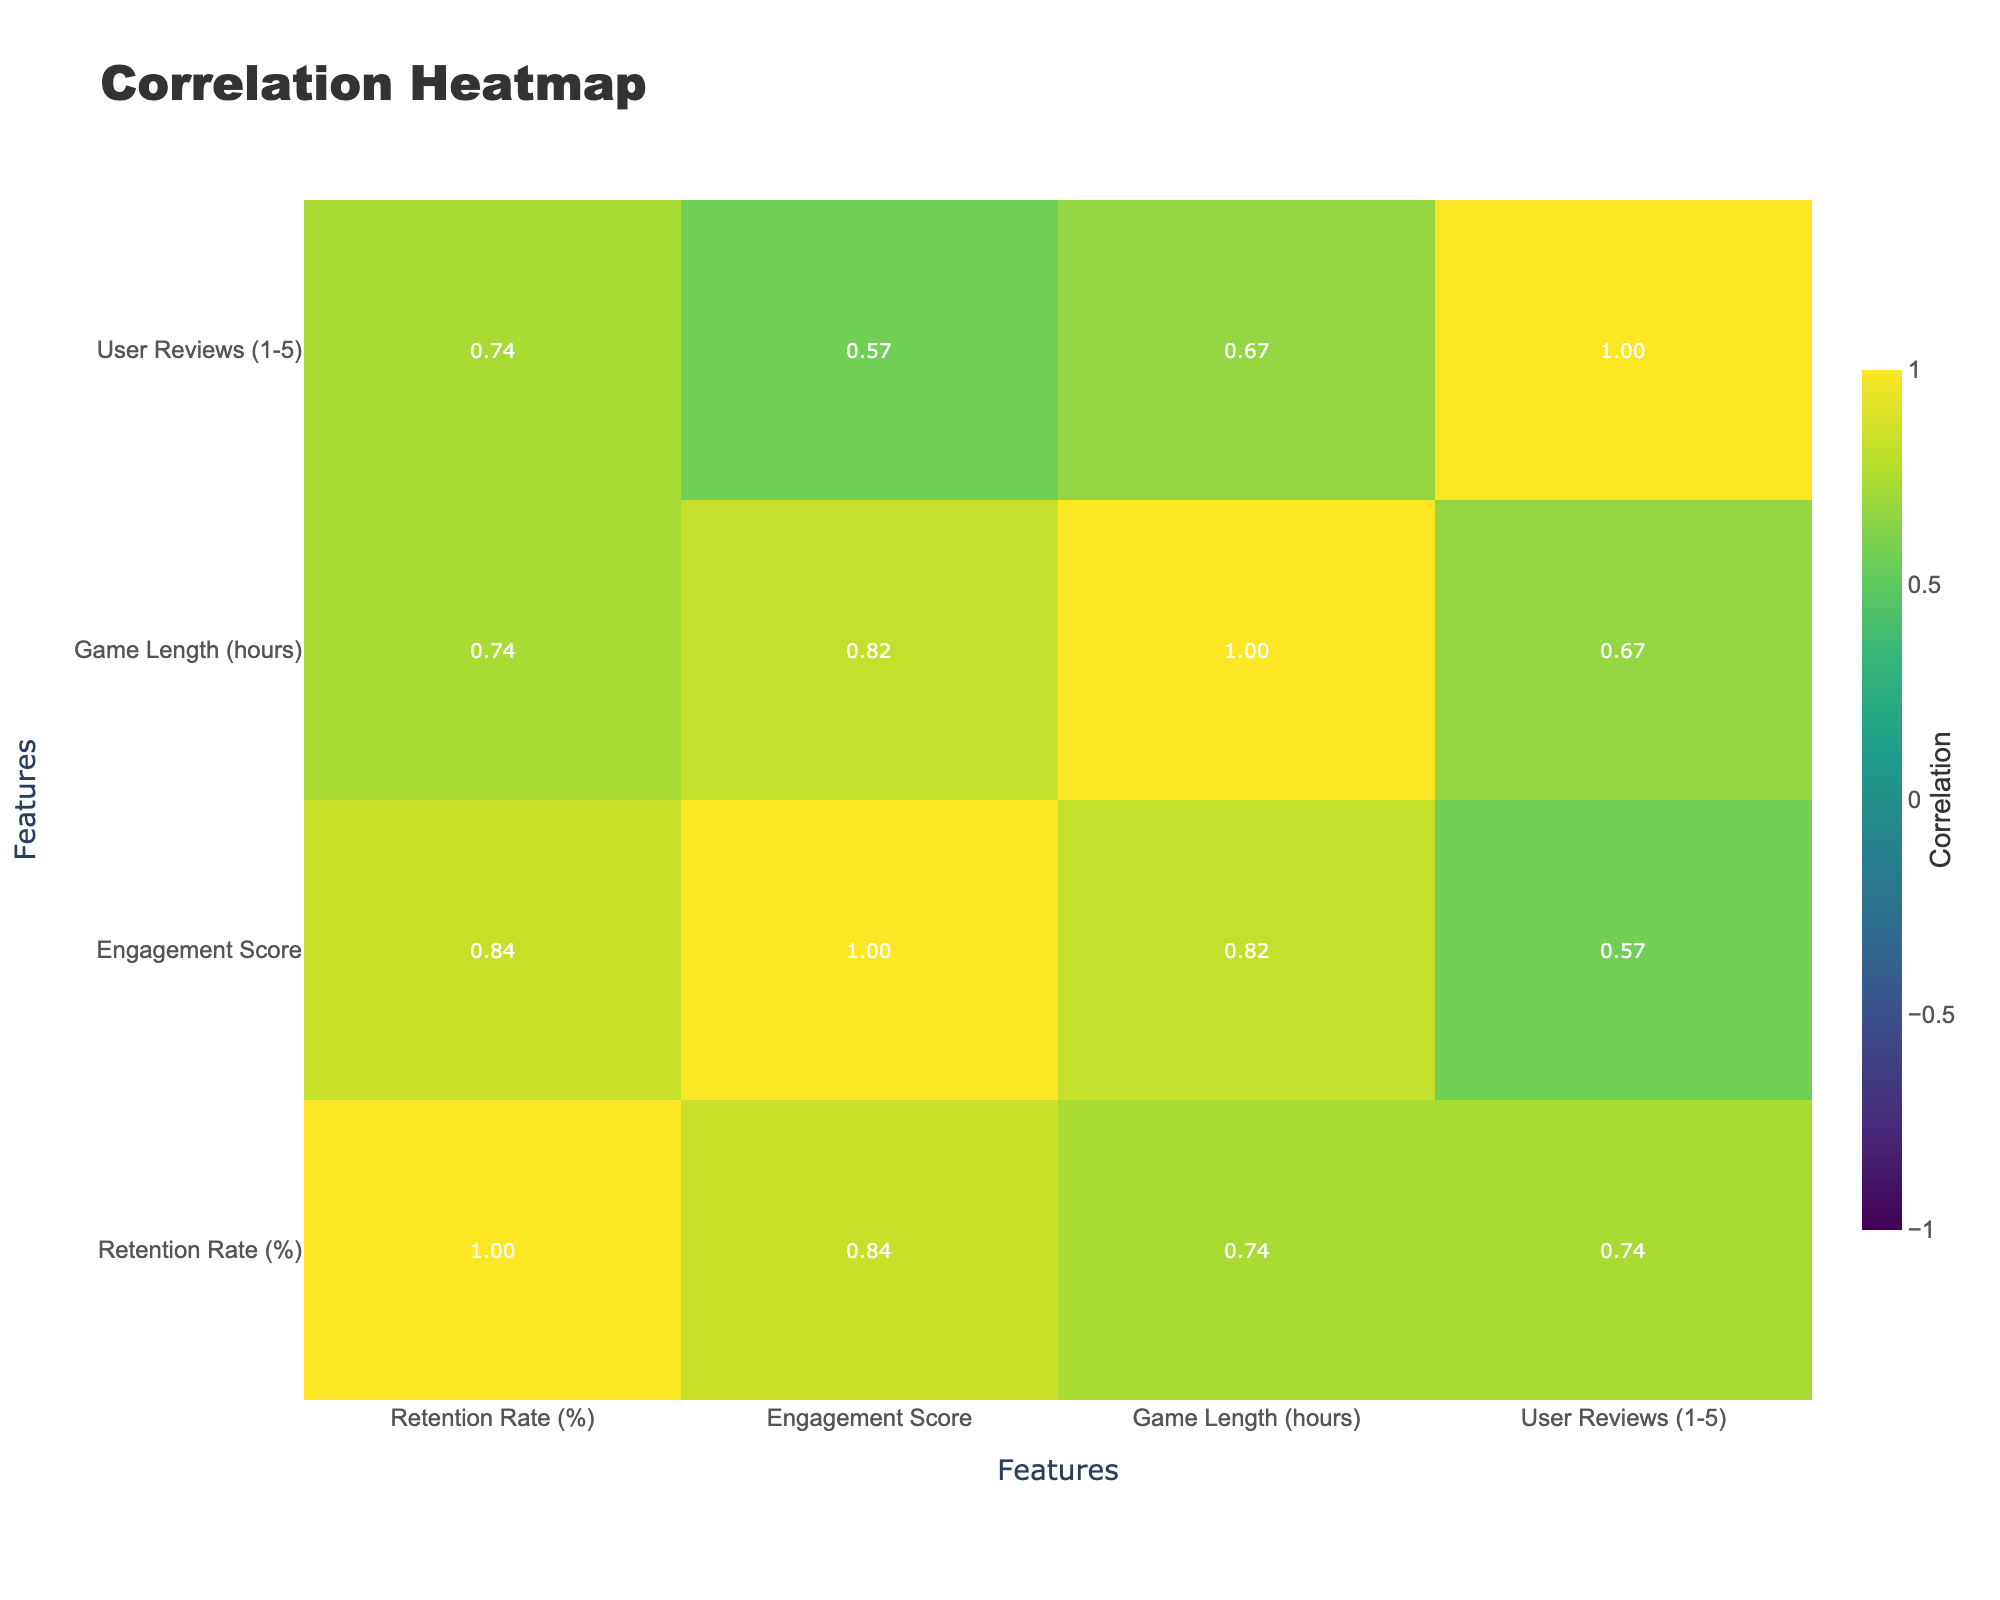What is the retention rate of Minecraft? The retention rate for Minecraft can be directly retrieved from the table, which shows a rate of 88%.
Answer: 88% What game has the highest engagement score? By scanning through the engagement scores listed, Minecraft has the highest score at 9.8.
Answer: 9.8 Is Red Dead Redemption 2 a free-to-play game? The game type (monetization strategy) for Red Dead Redemption 2 is listed as "Premium purchase," indicating it is not a free-to-play game.
Answer: No Which game has the lowest user reviews score? Looking at the user reviews, Call of Duty: Warzone has the lowest score of 4.1, confirming it ranks last in this metric.
Answer: 4.1 What is the average game length of all titles listed? First, sum the game lengths: 50 + 40 + 10 + 30 + 60 + 25 + 100 + 15 + 25 + 100 = 410. There are 10 titles, so the average game length is 410/10 = 41.
Answer: 41 Is there a correlation between engagement score and retention rate? To establish this, observe the correlation coefficient for "Engagement Score" and "Retention Rate" in the table. A positive correlation would suggest that as engagement increases, retention also increases. Since we’ll check the value, if it's above 0.5, we conclude a positive correlation exists.
Answer: Yes, if correlation is >0.5 (assumed from exploration) What is the difference between the highest and lowest retention rates? The highest retention rate is from Red Dead Redemption 2 at 90%, and the lowest is Among Us at 72%. The difference is calculated as 90 - 72 = 18.
Answer: 18 How many games have a retention rate greater than 80%? By examining the retention rates, the games that exceed 80% are The Legend of Zelda: Breath of the Wild, Genshin Impact, Red Dead Redemption 2, and Minecraft. That gives us a total of 4 games with retention rates above 80%.
Answer: 4 What is the average user review score for free-to-play games? The user reviews for free-to-play games listed are Fortnite (4.4), Among Us (4.6), Genshin Impact (4.5), League of Legends (4.3), Call of Duty: Warzone (4.1), and Apex Legends (4.2). Sum these: 4.4 + 4.6 + 4.5 + 4.3 + 4.1 + 4.2 = 26.2. There are 6 titles, so the average is 26.2/6 ≈ 4.37.
Answer: 4.37 